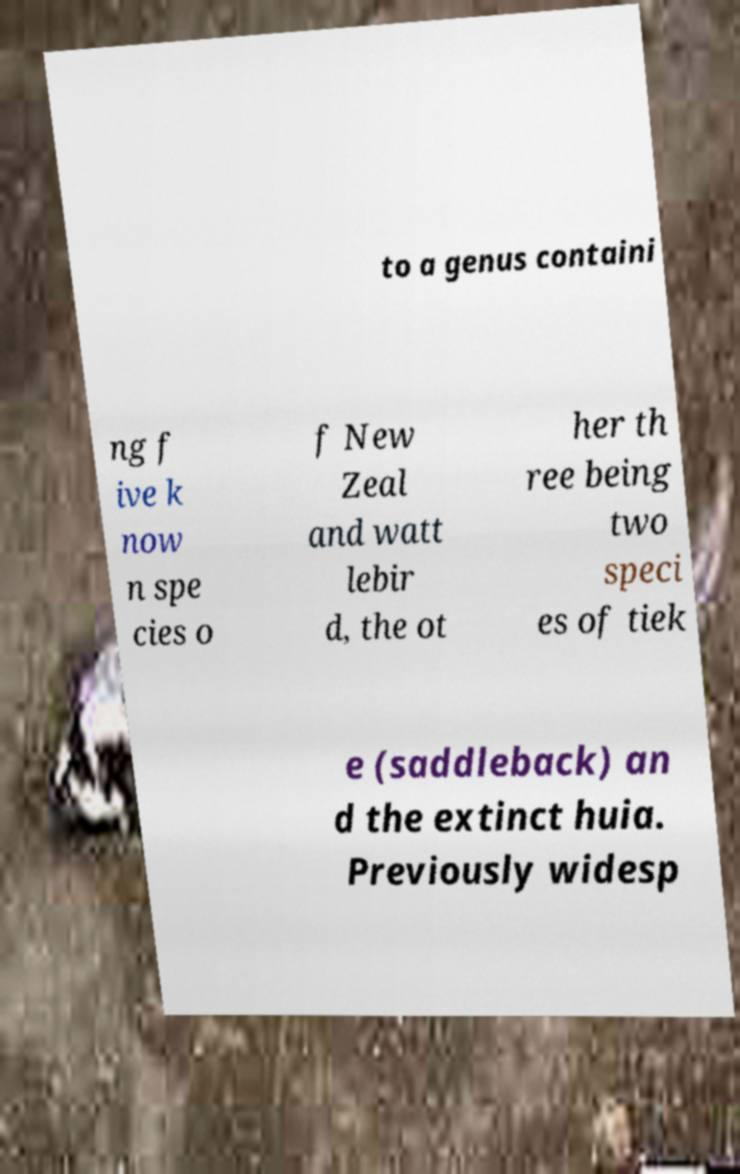There's text embedded in this image that I need extracted. Can you transcribe it verbatim? to a genus containi ng f ive k now n spe cies o f New Zeal and watt lebir d, the ot her th ree being two speci es of tiek e (saddleback) an d the extinct huia. Previously widesp 